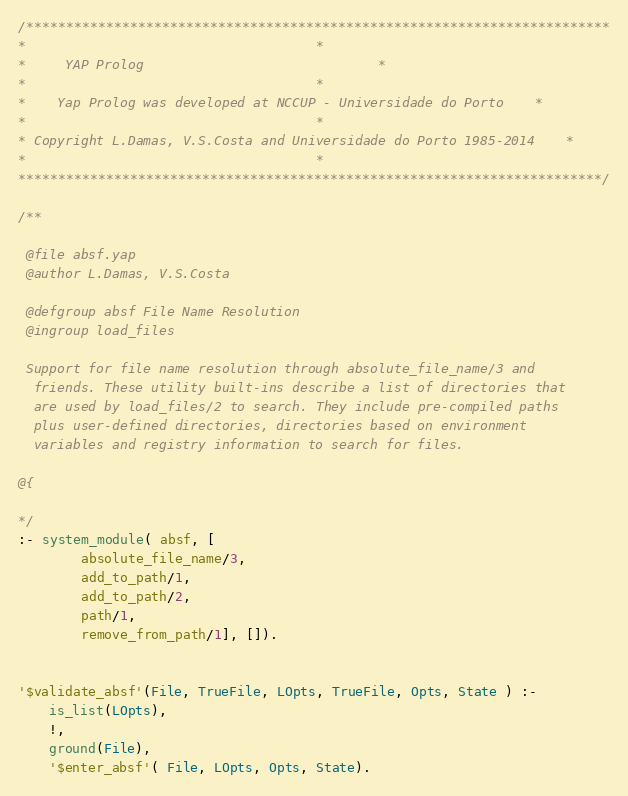<code> <loc_0><loc_0><loc_500><loc_500><_Prolog_>/*************************************************************************
*									 *
*	 YAP Prolog 							 *
*									 *
*	Yap Prolog was developed at NCCUP - Universidade do Porto	 *
*									 *
* Copyright L.Damas, V.S.Costa and Universidade do Porto 1985-2014	 *
*									 *
*************************************************************************/

/**

 @file absf.yap
 @author L.Damas, V.S.Costa

 @defgroup absf File Name Resolution
 @ingroup load_files

 Support for file name resolution through absolute_file_name/3 and
  friends. These utility built-ins describe a list of directories that
  are used by load_files/2 to search. They include pre-compiled paths
  plus user-defined directories, directories based on environment
  variables and registry information to search for files.

@{

*/
:- system_module( absf, [
        absolute_file_name/3,
        add_to_path/1,
        add_to_path/2,
        path/1,
        remove_from_path/1], []).


'$validate_absf'(File, TrueFile, LOpts, TrueFile, Opts, State ) :-
	is_list(LOpts),
	!,
	ground(File),
	'$enter_absf'( File, LOpts, Opts, State).</code> 